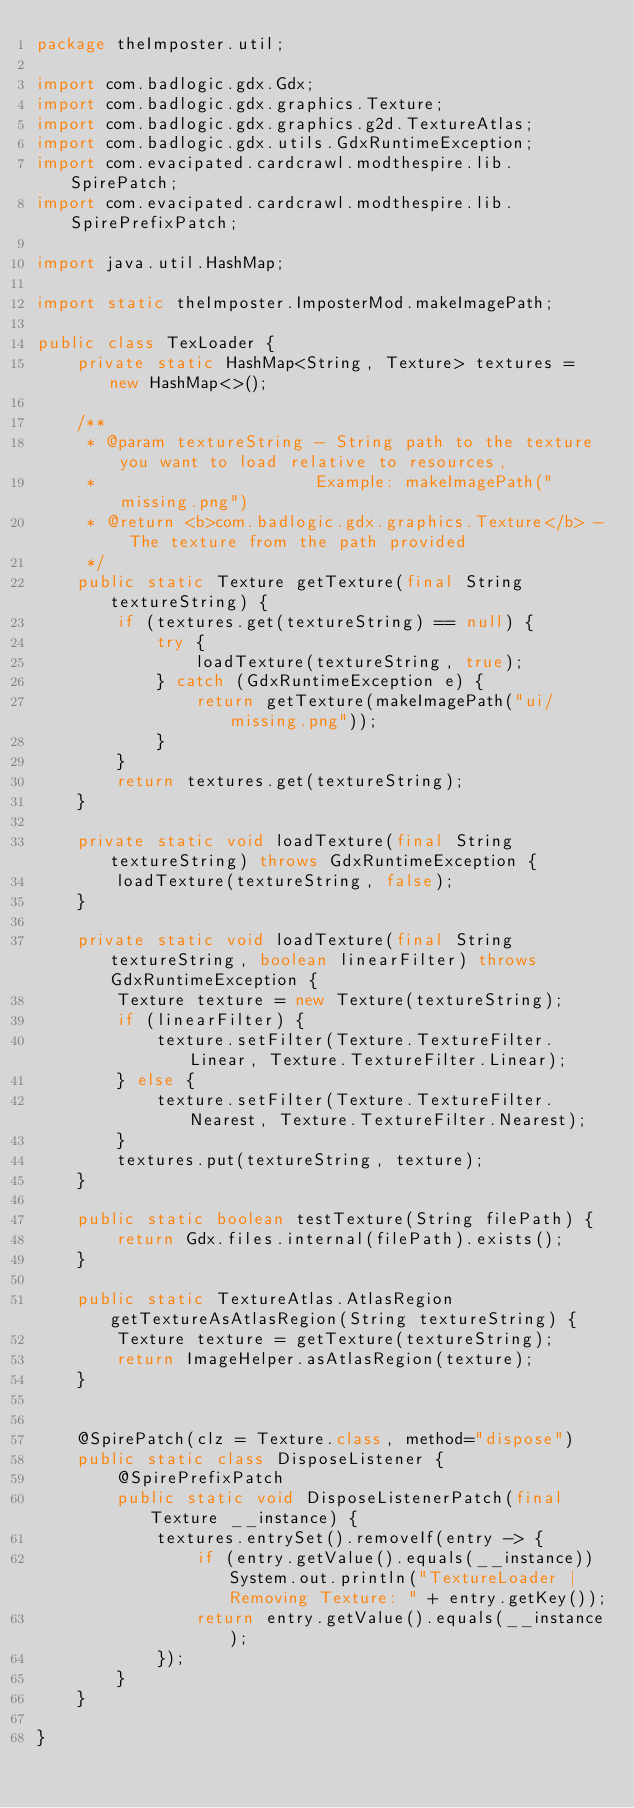<code> <loc_0><loc_0><loc_500><loc_500><_Java_>package theImposter.util;

import com.badlogic.gdx.Gdx;
import com.badlogic.gdx.graphics.Texture;
import com.badlogic.gdx.graphics.g2d.TextureAtlas;
import com.badlogic.gdx.utils.GdxRuntimeException;
import com.evacipated.cardcrawl.modthespire.lib.SpirePatch;
import com.evacipated.cardcrawl.modthespire.lib.SpirePrefixPatch;

import java.util.HashMap;

import static theImposter.ImposterMod.makeImagePath;

public class TexLoader {
    private static HashMap<String, Texture> textures = new HashMap<>();

    /**
     * @param textureString - String path to the texture you want to load relative to resources,
     *                      Example: makeImagePath("missing.png")
     * @return <b>com.badlogic.gdx.graphics.Texture</b> - The texture from the path provided
     */
    public static Texture getTexture(final String textureString) {
        if (textures.get(textureString) == null) {
            try {
                loadTexture(textureString, true);
            } catch (GdxRuntimeException e) {
                return getTexture(makeImagePath("ui/missing.png"));
            }
        }
        return textures.get(textureString);
    }

    private static void loadTexture(final String textureString) throws GdxRuntimeException {
        loadTexture(textureString, false);
    }

    private static void loadTexture(final String textureString, boolean linearFilter) throws GdxRuntimeException {
        Texture texture = new Texture(textureString);
        if (linearFilter) {
            texture.setFilter(Texture.TextureFilter.Linear, Texture.TextureFilter.Linear);
        } else {
            texture.setFilter(Texture.TextureFilter.Nearest, Texture.TextureFilter.Nearest);
        }
        textures.put(textureString, texture);
    }

    public static boolean testTexture(String filePath) {
        return Gdx.files.internal(filePath).exists();
    }

    public static TextureAtlas.AtlasRegion getTextureAsAtlasRegion(String textureString) {
        Texture texture = getTexture(textureString);
        return ImageHelper.asAtlasRegion(texture);
    }


    @SpirePatch(clz = Texture.class, method="dispose")
    public static class DisposeListener {
        @SpirePrefixPatch
        public static void DisposeListenerPatch(final Texture __instance) {
            textures.entrySet().removeIf(entry -> {
                if (entry.getValue().equals(__instance)) System.out.println("TextureLoader | Removing Texture: " + entry.getKey());
                return entry.getValue().equals(__instance);
            });
        }
    }

}</code> 